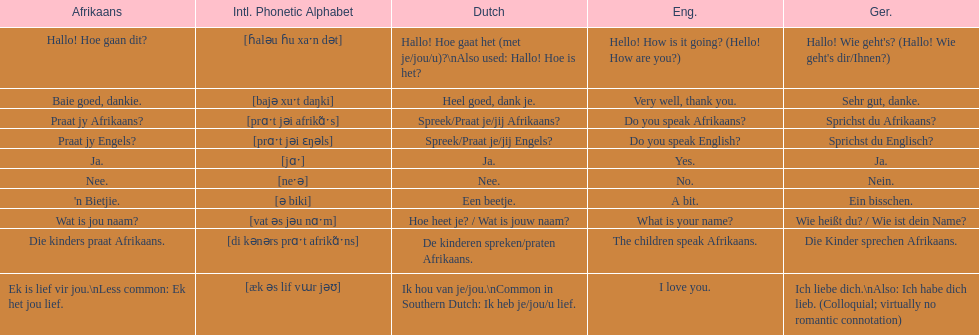How do you say "do you speak afrikaans?" in afrikaans? Praat jy Afrikaans?. 